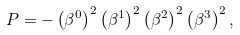<formula> <loc_0><loc_0><loc_500><loc_500>P = - \left ( \beta ^ { 0 } \right ) ^ { 2 } \left ( \beta ^ { 1 } \right ) ^ { 2 } \left ( \beta ^ { 2 } \right ) ^ { 2 } \left ( \beta ^ { 3 } \right ) ^ { 2 } ,</formula> 